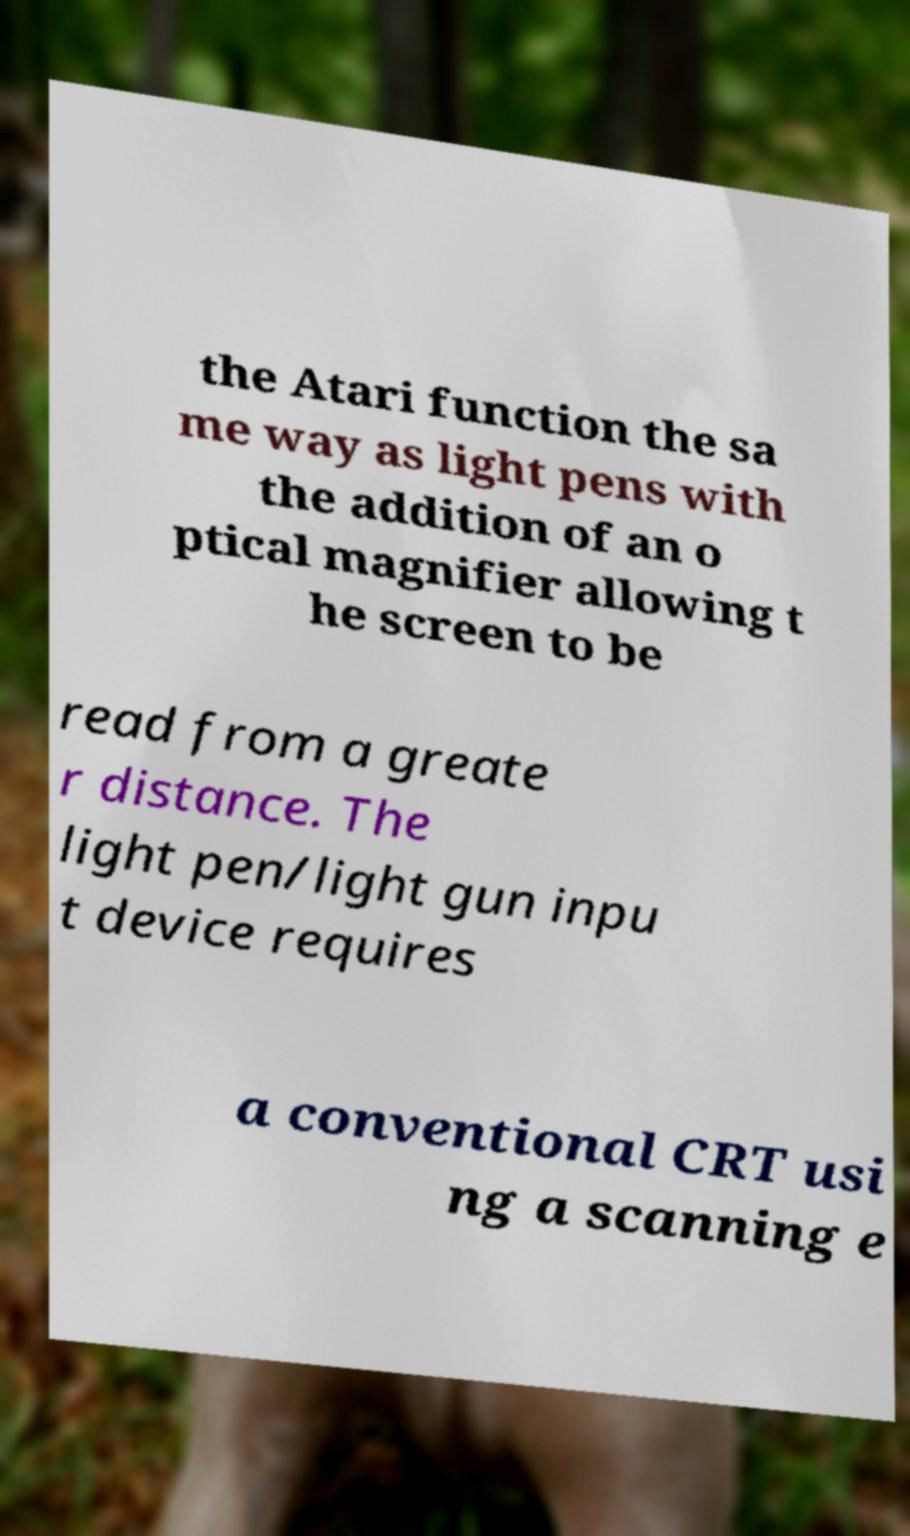There's text embedded in this image that I need extracted. Can you transcribe it verbatim? the Atari function the sa me way as light pens with the addition of an o ptical magnifier allowing t he screen to be read from a greate r distance. The light pen/light gun inpu t device requires a conventional CRT usi ng a scanning e 